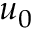<formula> <loc_0><loc_0><loc_500><loc_500>u _ { 0 }</formula> 